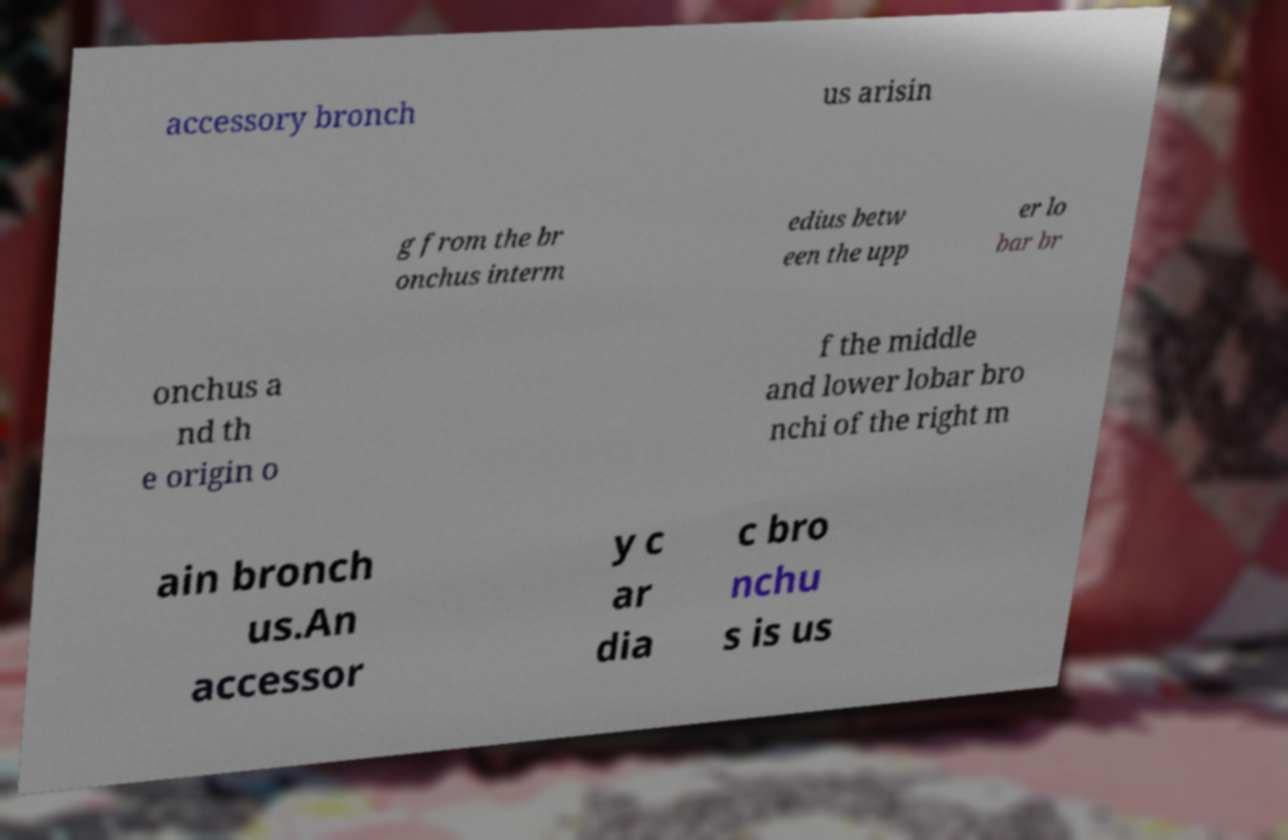What messages or text are displayed in this image? I need them in a readable, typed format. accessory bronch us arisin g from the br onchus interm edius betw een the upp er lo bar br onchus a nd th e origin o f the middle and lower lobar bro nchi of the right m ain bronch us.An accessor y c ar dia c bro nchu s is us 